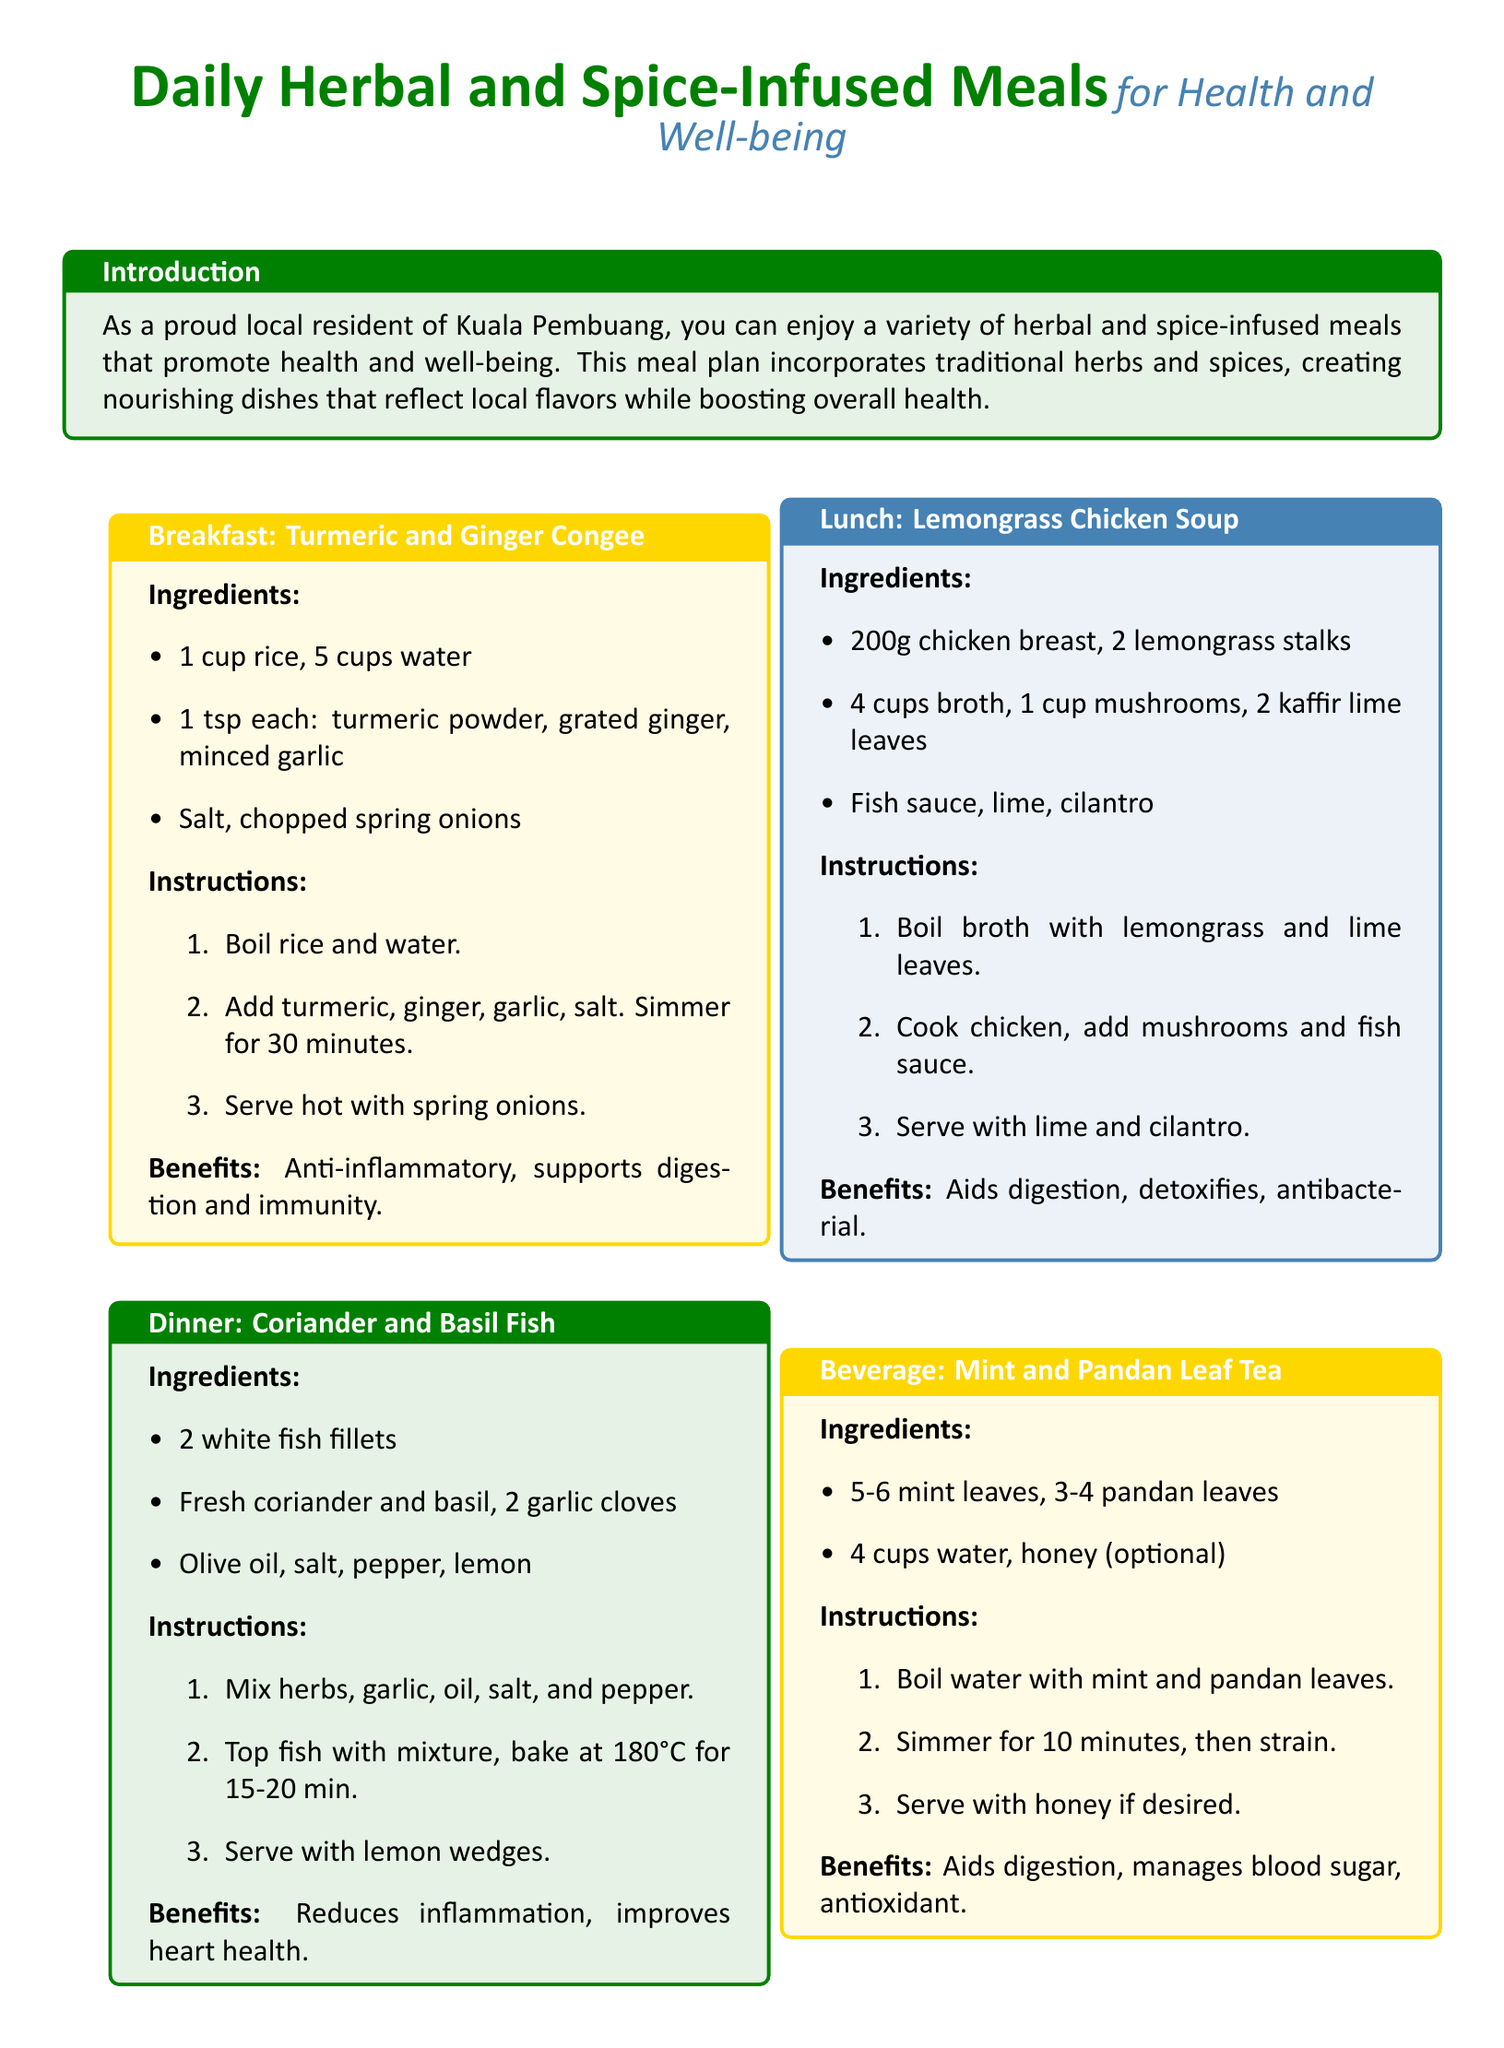What is the title of the meal plan? The title is prominently displayed at the beginning of the document, reading "Daily Herbal and Spice-Infused Meals."
Answer: Daily Herbal and Spice-Infused Meals What is one benefit of the Turmeric and Ginger Congee? The benefits are listed under the recipe, and one is that it is anti-inflammatory.
Answer: Anti-inflammatory How long should the rice simmer in the congee? The instructions for cooking specify that the rice should simmer for 30 minutes.
Answer: 30 minutes What main ingredient is used in the Lunch recipe? The recipe lists chicken breast as the primary ingredient for the Lemongrass Chicken Soup.
Answer: Chicken breast Which herbs are used in the Dinner recipe? The Dinner recipe mentions the use of fresh coriander and basil.
Answer: Fresh coriander and basil How many mint leaves are required for the beverage? The ingredients for the Mint and Pandan Leaf Tea indicate the use of 5-6 mint leaves.
Answer: 5-6 mint leaves What is the cooking temperature for the fish in the Dinner recipe? The instructions state that the fish should be baked at 180°C.
Answer: 180°C What optional ingredient can be added to the Mint and Pandan Leaf Tea? The recipe mentions that honey is an optional ingredient.
Answer: Honey What are the two main spices in the Breakfast dish? The Breakfast dish features turmeric and ginger as the two main spices.
Answer: Turmeric and ginger 